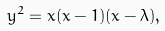Convert formula to latex. <formula><loc_0><loc_0><loc_500><loc_500>y ^ { 2 } = x ( x - 1 ) ( x - \lambda ) ,</formula> 